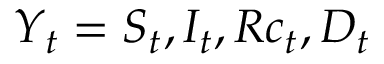Convert formula to latex. <formula><loc_0><loc_0><loc_500><loc_500>Y _ { t } = S _ { t } , I _ { t } , R c _ { t } , D _ { t }</formula> 